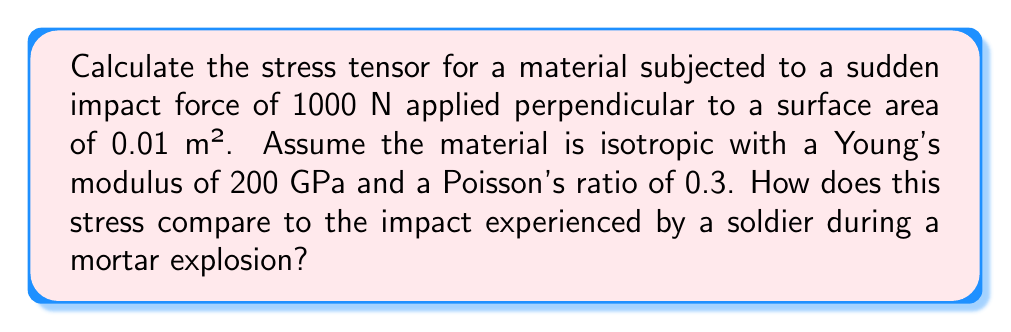Help me with this question. Let's approach this step-by-step:

1) First, we need to calculate the stress caused by the impact. The stress is given by force divided by area:

   $$\sigma = \frac{F}{A} = \frac{1000 \text{ N}}{0.01 \text{ m}^2} = 100,000 \text{ Pa} = 100 \text{ MPa}$$

2) For an isotropic material under uniaxial stress, the stress tensor in Cartesian coordinates is:

   $$\sigma_{ij} = \begin{pmatrix}
   \sigma_{xx} & 0 & 0 \\
   0 & 0 & 0 \\
   0 & 0 & 0
   \end{pmatrix}$$

   Where $\sigma_{xx}$ is the stress we calculated in step 1.

3) However, due to Poisson's effect, there will be lateral strains. We can calculate these using Hooke's law for isotropic materials:

   $$\epsilon_{yy} = \epsilon_{zz} = -\nu \frac{\sigma_{xx}}{E}$$

   Where $\nu$ is Poisson's ratio and $E$ is Young's modulus.

4) Substituting the values:

   $$\epsilon_{yy} = \epsilon_{zz} = -0.3 \frac{100 \text{ MPa}}{200 \text{ GPa}} = -0.00015$$

5) The lateral stresses can be calculated as:

   $$\sigma_{yy} = \sigma_{zz} = E \epsilon_{yy} = 200 \text{ GPa} \times (-0.00015) = -30 \text{ MPa}$$

6) Therefore, the complete stress tensor is:

   $$\sigma_{ij} = \begin{pmatrix}
   100 & 0 & 0 \\
   0 & -30 & 0 \\
   0 & 0 & -30
   \end{pmatrix} \text{ MPa}$$

7) Comparing to a mortar explosion: The stress experienced here (100 MPa) is significant but localized. A mortar explosion would create a pressure wave with peak overpressures that can exceed 1000 MPa near the blast, potentially causing severe trauma. The stress distribution would also be more complex, involving shear stresses and rapid time variations not captured in this simplified model.
Answer: $$\sigma_{ij} = \begin{pmatrix}
100 & 0 & 0 \\
0 & -30 & 0 \\
0 & 0 & -30
\end{pmatrix} \text{ MPa}$$ 